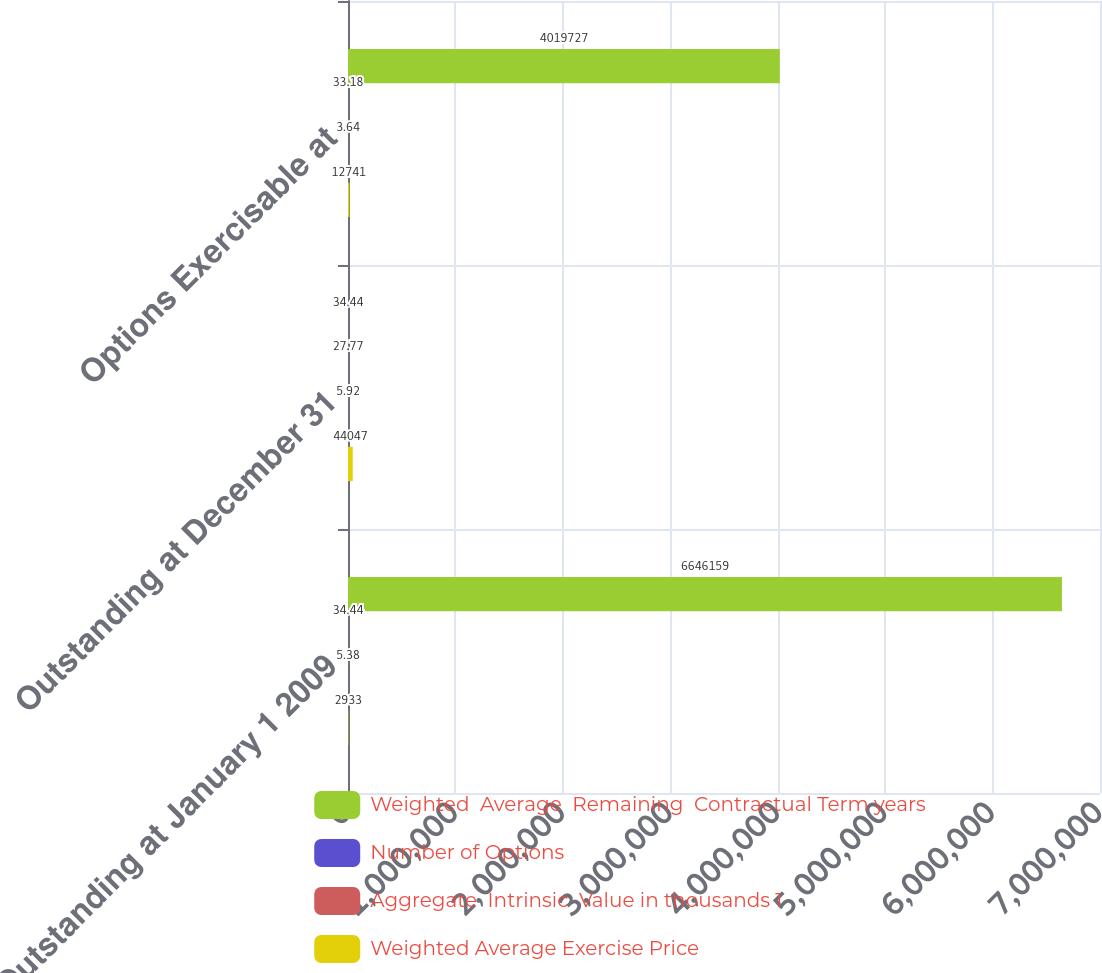Convert chart to OTSL. <chart><loc_0><loc_0><loc_500><loc_500><stacked_bar_chart><ecel><fcel>Outstanding at January 1 2009<fcel>Outstanding at December 31<fcel>Options Exercisable at<nl><fcel>Weighted  Average  Remaining  Contractual Term years<fcel>6.64616e+06<fcel>34.44<fcel>4.01973e+06<nl><fcel>Number of Options<fcel>34.44<fcel>27.77<fcel>33.18<nl><fcel>Aggregate  Intrinsic  Value in thousands 1<fcel>5.38<fcel>5.92<fcel>3.64<nl><fcel>Weighted Average Exercise Price<fcel>2933<fcel>44047<fcel>12741<nl></chart> 